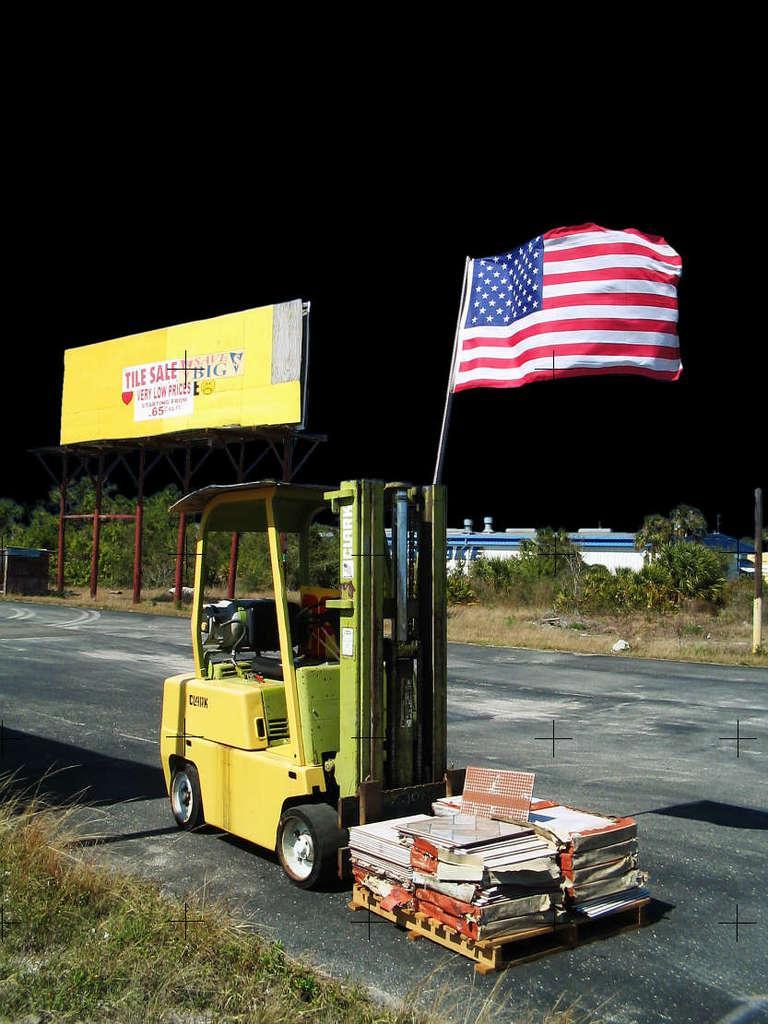Describe this image in one or two sentences. In this image I can see the vehicle and some objects on the road. I can see the flags to the yellow color vehicle. In the background I can see the railing, board and the trees. And there is a black background. 